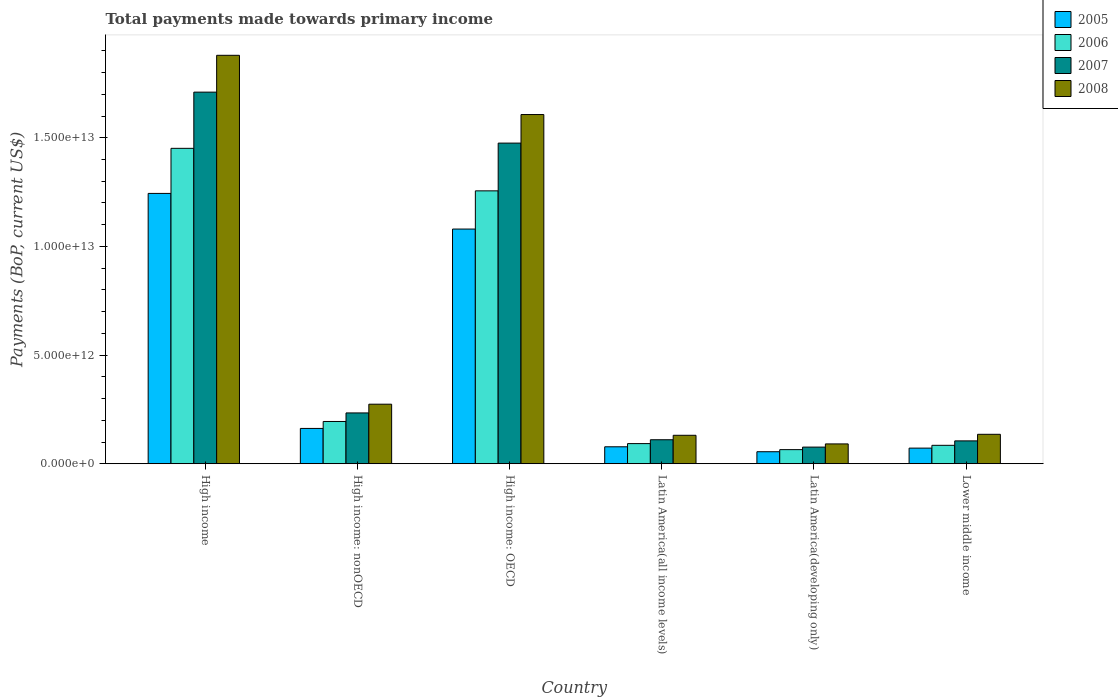How many different coloured bars are there?
Your answer should be compact. 4. How many groups of bars are there?
Provide a succinct answer. 6. Are the number of bars per tick equal to the number of legend labels?
Your response must be concise. Yes. Are the number of bars on each tick of the X-axis equal?
Provide a succinct answer. Yes. What is the label of the 5th group of bars from the left?
Provide a succinct answer. Latin America(developing only). In how many cases, is the number of bars for a given country not equal to the number of legend labels?
Provide a succinct answer. 0. What is the total payments made towards primary income in 2008 in High income: OECD?
Your response must be concise. 1.61e+13. Across all countries, what is the maximum total payments made towards primary income in 2007?
Offer a terse response. 1.71e+13. Across all countries, what is the minimum total payments made towards primary income in 2005?
Your answer should be very brief. 5.52e+11. In which country was the total payments made towards primary income in 2007 minimum?
Give a very brief answer. Latin America(developing only). What is the total total payments made towards primary income in 2008 in the graph?
Offer a terse response. 4.12e+13. What is the difference between the total payments made towards primary income in 2005 in High income and that in Latin America(all income levels)?
Offer a terse response. 1.17e+13. What is the difference between the total payments made towards primary income in 2006 in High income: OECD and the total payments made towards primary income in 2008 in Latin America(developing only)?
Your response must be concise. 1.16e+13. What is the average total payments made towards primary income in 2007 per country?
Your answer should be very brief. 6.19e+12. What is the difference between the total payments made towards primary income of/in 2007 and total payments made towards primary income of/in 2005 in High income: nonOECD?
Offer a terse response. 7.13e+11. In how many countries, is the total payments made towards primary income in 2005 greater than 10000000000000 US$?
Your answer should be compact. 2. What is the ratio of the total payments made towards primary income in 2005 in High income to that in Latin America(all income levels)?
Your answer should be compact. 15.95. What is the difference between the highest and the second highest total payments made towards primary income in 2006?
Your answer should be compact. 1.06e+13. What is the difference between the highest and the lowest total payments made towards primary income in 2005?
Keep it short and to the point. 1.19e+13. Is the sum of the total payments made towards primary income in 2008 in Latin America(all income levels) and Lower middle income greater than the maximum total payments made towards primary income in 2007 across all countries?
Provide a short and direct response. No. Is it the case that in every country, the sum of the total payments made towards primary income in 2007 and total payments made towards primary income in 2008 is greater than the sum of total payments made towards primary income in 2006 and total payments made towards primary income in 2005?
Your response must be concise. No. Are all the bars in the graph horizontal?
Provide a succinct answer. No. How many countries are there in the graph?
Give a very brief answer. 6. What is the difference between two consecutive major ticks on the Y-axis?
Ensure brevity in your answer.  5.00e+12. Does the graph contain grids?
Provide a succinct answer. No. What is the title of the graph?
Ensure brevity in your answer.  Total payments made towards primary income. What is the label or title of the Y-axis?
Keep it short and to the point. Payments (BoP, current US$). What is the Payments (BoP, current US$) of 2005 in High income?
Your response must be concise. 1.24e+13. What is the Payments (BoP, current US$) of 2006 in High income?
Make the answer very short. 1.45e+13. What is the Payments (BoP, current US$) in 2007 in High income?
Ensure brevity in your answer.  1.71e+13. What is the Payments (BoP, current US$) of 2008 in High income?
Your response must be concise. 1.88e+13. What is the Payments (BoP, current US$) of 2005 in High income: nonOECD?
Offer a terse response. 1.62e+12. What is the Payments (BoP, current US$) of 2006 in High income: nonOECD?
Keep it short and to the point. 1.94e+12. What is the Payments (BoP, current US$) in 2007 in High income: nonOECD?
Give a very brief answer. 2.34e+12. What is the Payments (BoP, current US$) of 2008 in High income: nonOECD?
Your answer should be compact. 2.74e+12. What is the Payments (BoP, current US$) in 2005 in High income: OECD?
Your answer should be compact. 1.08e+13. What is the Payments (BoP, current US$) in 2006 in High income: OECD?
Give a very brief answer. 1.26e+13. What is the Payments (BoP, current US$) in 2007 in High income: OECD?
Offer a very short reply. 1.48e+13. What is the Payments (BoP, current US$) in 2008 in High income: OECD?
Your answer should be compact. 1.61e+13. What is the Payments (BoP, current US$) of 2005 in Latin America(all income levels)?
Make the answer very short. 7.80e+11. What is the Payments (BoP, current US$) in 2006 in Latin America(all income levels)?
Your response must be concise. 9.27e+11. What is the Payments (BoP, current US$) of 2007 in Latin America(all income levels)?
Your answer should be very brief. 1.10e+12. What is the Payments (BoP, current US$) in 2008 in Latin America(all income levels)?
Keep it short and to the point. 1.31e+12. What is the Payments (BoP, current US$) in 2005 in Latin America(developing only)?
Your response must be concise. 5.52e+11. What is the Payments (BoP, current US$) of 2006 in Latin America(developing only)?
Offer a very short reply. 6.49e+11. What is the Payments (BoP, current US$) of 2007 in Latin America(developing only)?
Offer a terse response. 7.65e+11. What is the Payments (BoP, current US$) of 2008 in Latin America(developing only)?
Ensure brevity in your answer.  9.12e+11. What is the Payments (BoP, current US$) of 2005 in Lower middle income?
Provide a short and direct response. 7.19e+11. What is the Payments (BoP, current US$) in 2006 in Lower middle income?
Provide a short and direct response. 8.48e+11. What is the Payments (BoP, current US$) in 2007 in Lower middle income?
Offer a terse response. 1.05e+12. What is the Payments (BoP, current US$) of 2008 in Lower middle income?
Your answer should be very brief. 1.35e+12. Across all countries, what is the maximum Payments (BoP, current US$) of 2005?
Offer a terse response. 1.24e+13. Across all countries, what is the maximum Payments (BoP, current US$) of 2006?
Make the answer very short. 1.45e+13. Across all countries, what is the maximum Payments (BoP, current US$) in 2007?
Keep it short and to the point. 1.71e+13. Across all countries, what is the maximum Payments (BoP, current US$) of 2008?
Give a very brief answer. 1.88e+13. Across all countries, what is the minimum Payments (BoP, current US$) in 2005?
Offer a terse response. 5.52e+11. Across all countries, what is the minimum Payments (BoP, current US$) of 2006?
Your answer should be very brief. 6.49e+11. Across all countries, what is the minimum Payments (BoP, current US$) of 2007?
Keep it short and to the point. 7.65e+11. Across all countries, what is the minimum Payments (BoP, current US$) of 2008?
Keep it short and to the point. 9.12e+11. What is the total Payments (BoP, current US$) in 2005 in the graph?
Provide a succinct answer. 2.69e+13. What is the total Payments (BoP, current US$) in 2006 in the graph?
Make the answer very short. 3.14e+13. What is the total Payments (BoP, current US$) of 2007 in the graph?
Offer a terse response. 3.71e+13. What is the total Payments (BoP, current US$) of 2008 in the graph?
Give a very brief answer. 4.12e+13. What is the difference between the Payments (BoP, current US$) of 2005 in High income and that in High income: nonOECD?
Your answer should be compact. 1.08e+13. What is the difference between the Payments (BoP, current US$) of 2006 in High income and that in High income: nonOECD?
Provide a succinct answer. 1.26e+13. What is the difference between the Payments (BoP, current US$) of 2007 in High income and that in High income: nonOECD?
Provide a succinct answer. 1.48e+13. What is the difference between the Payments (BoP, current US$) in 2008 in High income and that in High income: nonOECD?
Give a very brief answer. 1.61e+13. What is the difference between the Payments (BoP, current US$) of 2005 in High income and that in High income: OECD?
Ensure brevity in your answer.  1.64e+12. What is the difference between the Payments (BoP, current US$) in 2006 in High income and that in High income: OECD?
Provide a succinct answer. 1.96e+12. What is the difference between the Payments (BoP, current US$) in 2007 in High income and that in High income: OECD?
Keep it short and to the point. 2.35e+12. What is the difference between the Payments (BoP, current US$) of 2008 in High income and that in High income: OECD?
Ensure brevity in your answer.  2.73e+12. What is the difference between the Payments (BoP, current US$) in 2005 in High income and that in Latin America(all income levels)?
Provide a succinct answer. 1.17e+13. What is the difference between the Payments (BoP, current US$) of 2006 in High income and that in Latin America(all income levels)?
Your answer should be compact. 1.36e+13. What is the difference between the Payments (BoP, current US$) in 2007 in High income and that in Latin America(all income levels)?
Your answer should be very brief. 1.60e+13. What is the difference between the Payments (BoP, current US$) of 2008 in High income and that in Latin America(all income levels)?
Make the answer very short. 1.75e+13. What is the difference between the Payments (BoP, current US$) of 2005 in High income and that in Latin America(developing only)?
Offer a terse response. 1.19e+13. What is the difference between the Payments (BoP, current US$) of 2006 in High income and that in Latin America(developing only)?
Offer a terse response. 1.39e+13. What is the difference between the Payments (BoP, current US$) of 2007 in High income and that in Latin America(developing only)?
Make the answer very short. 1.63e+13. What is the difference between the Payments (BoP, current US$) in 2008 in High income and that in Latin America(developing only)?
Your response must be concise. 1.79e+13. What is the difference between the Payments (BoP, current US$) of 2005 in High income and that in Lower middle income?
Offer a terse response. 1.17e+13. What is the difference between the Payments (BoP, current US$) in 2006 in High income and that in Lower middle income?
Ensure brevity in your answer.  1.37e+13. What is the difference between the Payments (BoP, current US$) of 2007 in High income and that in Lower middle income?
Your answer should be compact. 1.60e+13. What is the difference between the Payments (BoP, current US$) of 2008 in High income and that in Lower middle income?
Your response must be concise. 1.74e+13. What is the difference between the Payments (BoP, current US$) of 2005 in High income: nonOECD and that in High income: OECD?
Your response must be concise. -9.17e+12. What is the difference between the Payments (BoP, current US$) of 2006 in High income: nonOECD and that in High income: OECD?
Offer a terse response. -1.06e+13. What is the difference between the Payments (BoP, current US$) of 2007 in High income: nonOECD and that in High income: OECD?
Your response must be concise. -1.24e+13. What is the difference between the Payments (BoP, current US$) in 2008 in High income: nonOECD and that in High income: OECD?
Your response must be concise. -1.33e+13. What is the difference between the Payments (BoP, current US$) of 2005 in High income: nonOECD and that in Latin America(all income levels)?
Your answer should be compact. 8.45e+11. What is the difference between the Payments (BoP, current US$) of 2006 in High income: nonOECD and that in Latin America(all income levels)?
Keep it short and to the point. 1.02e+12. What is the difference between the Payments (BoP, current US$) of 2007 in High income: nonOECD and that in Latin America(all income levels)?
Keep it short and to the point. 1.23e+12. What is the difference between the Payments (BoP, current US$) in 2008 in High income: nonOECD and that in Latin America(all income levels)?
Provide a succinct answer. 1.43e+12. What is the difference between the Payments (BoP, current US$) in 2005 in High income: nonOECD and that in Latin America(developing only)?
Your answer should be very brief. 1.07e+12. What is the difference between the Payments (BoP, current US$) of 2006 in High income: nonOECD and that in Latin America(developing only)?
Your response must be concise. 1.30e+12. What is the difference between the Payments (BoP, current US$) of 2007 in High income: nonOECD and that in Latin America(developing only)?
Your answer should be very brief. 1.57e+12. What is the difference between the Payments (BoP, current US$) in 2008 in High income: nonOECD and that in Latin America(developing only)?
Your answer should be very brief. 1.83e+12. What is the difference between the Payments (BoP, current US$) of 2005 in High income: nonOECD and that in Lower middle income?
Offer a terse response. 9.06e+11. What is the difference between the Payments (BoP, current US$) of 2006 in High income: nonOECD and that in Lower middle income?
Ensure brevity in your answer.  1.10e+12. What is the difference between the Payments (BoP, current US$) of 2007 in High income: nonOECD and that in Lower middle income?
Offer a terse response. 1.29e+12. What is the difference between the Payments (BoP, current US$) of 2008 in High income: nonOECD and that in Lower middle income?
Your answer should be compact. 1.39e+12. What is the difference between the Payments (BoP, current US$) of 2005 in High income: OECD and that in Latin America(all income levels)?
Your answer should be compact. 1.00e+13. What is the difference between the Payments (BoP, current US$) in 2006 in High income: OECD and that in Latin America(all income levels)?
Your response must be concise. 1.16e+13. What is the difference between the Payments (BoP, current US$) in 2007 in High income: OECD and that in Latin America(all income levels)?
Provide a short and direct response. 1.36e+13. What is the difference between the Payments (BoP, current US$) of 2008 in High income: OECD and that in Latin America(all income levels)?
Provide a succinct answer. 1.48e+13. What is the difference between the Payments (BoP, current US$) of 2005 in High income: OECD and that in Latin America(developing only)?
Give a very brief answer. 1.02e+13. What is the difference between the Payments (BoP, current US$) of 2006 in High income: OECD and that in Latin America(developing only)?
Provide a succinct answer. 1.19e+13. What is the difference between the Payments (BoP, current US$) in 2007 in High income: OECD and that in Latin America(developing only)?
Provide a succinct answer. 1.40e+13. What is the difference between the Payments (BoP, current US$) of 2008 in High income: OECD and that in Latin America(developing only)?
Your response must be concise. 1.52e+13. What is the difference between the Payments (BoP, current US$) in 2005 in High income: OECD and that in Lower middle income?
Make the answer very short. 1.01e+13. What is the difference between the Payments (BoP, current US$) in 2006 in High income: OECD and that in Lower middle income?
Keep it short and to the point. 1.17e+13. What is the difference between the Payments (BoP, current US$) of 2007 in High income: OECD and that in Lower middle income?
Offer a very short reply. 1.37e+13. What is the difference between the Payments (BoP, current US$) of 2008 in High income: OECD and that in Lower middle income?
Offer a terse response. 1.47e+13. What is the difference between the Payments (BoP, current US$) in 2005 in Latin America(all income levels) and that in Latin America(developing only)?
Make the answer very short. 2.27e+11. What is the difference between the Payments (BoP, current US$) of 2006 in Latin America(all income levels) and that in Latin America(developing only)?
Your answer should be very brief. 2.78e+11. What is the difference between the Payments (BoP, current US$) of 2007 in Latin America(all income levels) and that in Latin America(developing only)?
Give a very brief answer. 3.39e+11. What is the difference between the Payments (BoP, current US$) of 2008 in Latin America(all income levels) and that in Latin America(developing only)?
Make the answer very short. 3.97e+11. What is the difference between the Payments (BoP, current US$) of 2005 in Latin America(all income levels) and that in Lower middle income?
Your answer should be compact. 6.05e+1. What is the difference between the Payments (BoP, current US$) in 2006 in Latin America(all income levels) and that in Lower middle income?
Provide a short and direct response. 7.89e+1. What is the difference between the Payments (BoP, current US$) of 2007 in Latin America(all income levels) and that in Lower middle income?
Offer a terse response. 5.23e+1. What is the difference between the Payments (BoP, current US$) of 2008 in Latin America(all income levels) and that in Lower middle income?
Your answer should be compact. -4.54e+1. What is the difference between the Payments (BoP, current US$) in 2005 in Latin America(developing only) and that in Lower middle income?
Provide a succinct answer. -1.67e+11. What is the difference between the Payments (BoP, current US$) of 2006 in Latin America(developing only) and that in Lower middle income?
Offer a terse response. -1.99e+11. What is the difference between the Payments (BoP, current US$) in 2007 in Latin America(developing only) and that in Lower middle income?
Provide a short and direct response. -2.86e+11. What is the difference between the Payments (BoP, current US$) of 2008 in Latin America(developing only) and that in Lower middle income?
Give a very brief answer. -4.42e+11. What is the difference between the Payments (BoP, current US$) in 2005 in High income and the Payments (BoP, current US$) in 2006 in High income: nonOECD?
Offer a very short reply. 1.05e+13. What is the difference between the Payments (BoP, current US$) of 2005 in High income and the Payments (BoP, current US$) of 2007 in High income: nonOECD?
Ensure brevity in your answer.  1.01e+13. What is the difference between the Payments (BoP, current US$) in 2005 in High income and the Payments (BoP, current US$) in 2008 in High income: nonOECD?
Keep it short and to the point. 9.70e+12. What is the difference between the Payments (BoP, current US$) in 2006 in High income and the Payments (BoP, current US$) in 2007 in High income: nonOECD?
Provide a succinct answer. 1.22e+13. What is the difference between the Payments (BoP, current US$) of 2006 in High income and the Payments (BoP, current US$) of 2008 in High income: nonOECD?
Give a very brief answer. 1.18e+13. What is the difference between the Payments (BoP, current US$) in 2007 in High income and the Payments (BoP, current US$) in 2008 in High income: nonOECD?
Keep it short and to the point. 1.44e+13. What is the difference between the Payments (BoP, current US$) in 2005 in High income and the Payments (BoP, current US$) in 2006 in High income: OECD?
Your response must be concise. -1.18e+11. What is the difference between the Payments (BoP, current US$) in 2005 in High income and the Payments (BoP, current US$) in 2007 in High income: OECD?
Give a very brief answer. -2.32e+12. What is the difference between the Payments (BoP, current US$) in 2005 in High income and the Payments (BoP, current US$) in 2008 in High income: OECD?
Offer a terse response. -3.63e+12. What is the difference between the Payments (BoP, current US$) of 2006 in High income and the Payments (BoP, current US$) of 2007 in High income: OECD?
Provide a short and direct response. -2.41e+11. What is the difference between the Payments (BoP, current US$) in 2006 in High income and the Payments (BoP, current US$) in 2008 in High income: OECD?
Make the answer very short. -1.55e+12. What is the difference between the Payments (BoP, current US$) of 2007 in High income and the Payments (BoP, current US$) of 2008 in High income: OECD?
Offer a very short reply. 1.03e+12. What is the difference between the Payments (BoP, current US$) of 2005 in High income and the Payments (BoP, current US$) of 2006 in Latin America(all income levels)?
Your answer should be very brief. 1.15e+13. What is the difference between the Payments (BoP, current US$) of 2005 in High income and the Payments (BoP, current US$) of 2007 in Latin America(all income levels)?
Make the answer very short. 1.13e+13. What is the difference between the Payments (BoP, current US$) of 2005 in High income and the Payments (BoP, current US$) of 2008 in Latin America(all income levels)?
Your response must be concise. 1.11e+13. What is the difference between the Payments (BoP, current US$) of 2006 in High income and the Payments (BoP, current US$) of 2007 in Latin America(all income levels)?
Ensure brevity in your answer.  1.34e+13. What is the difference between the Payments (BoP, current US$) of 2006 in High income and the Payments (BoP, current US$) of 2008 in Latin America(all income levels)?
Offer a very short reply. 1.32e+13. What is the difference between the Payments (BoP, current US$) of 2007 in High income and the Payments (BoP, current US$) of 2008 in Latin America(all income levels)?
Keep it short and to the point. 1.58e+13. What is the difference between the Payments (BoP, current US$) of 2005 in High income and the Payments (BoP, current US$) of 2006 in Latin America(developing only)?
Offer a very short reply. 1.18e+13. What is the difference between the Payments (BoP, current US$) of 2005 in High income and the Payments (BoP, current US$) of 2007 in Latin America(developing only)?
Your answer should be very brief. 1.17e+13. What is the difference between the Payments (BoP, current US$) of 2005 in High income and the Payments (BoP, current US$) of 2008 in Latin America(developing only)?
Your answer should be compact. 1.15e+13. What is the difference between the Payments (BoP, current US$) in 2006 in High income and the Payments (BoP, current US$) in 2007 in Latin America(developing only)?
Your answer should be compact. 1.37e+13. What is the difference between the Payments (BoP, current US$) in 2006 in High income and the Payments (BoP, current US$) in 2008 in Latin America(developing only)?
Provide a succinct answer. 1.36e+13. What is the difference between the Payments (BoP, current US$) of 2007 in High income and the Payments (BoP, current US$) of 2008 in Latin America(developing only)?
Keep it short and to the point. 1.62e+13. What is the difference between the Payments (BoP, current US$) in 2005 in High income and the Payments (BoP, current US$) in 2006 in Lower middle income?
Offer a very short reply. 1.16e+13. What is the difference between the Payments (BoP, current US$) of 2005 in High income and the Payments (BoP, current US$) of 2007 in Lower middle income?
Offer a very short reply. 1.14e+13. What is the difference between the Payments (BoP, current US$) in 2005 in High income and the Payments (BoP, current US$) in 2008 in Lower middle income?
Your response must be concise. 1.11e+13. What is the difference between the Payments (BoP, current US$) of 2006 in High income and the Payments (BoP, current US$) of 2007 in Lower middle income?
Your answer should be compact. 1.35e+13. What is the difference between the Payments (BoP, current US$) in 2006 in High income and the Payments (BoP, current US$) in 2008 in Lower middle income?
Provide a succinct answer. 1.32e+13. What is the difference between the Payments (BoP, current US$) in 2007 in High income and the Payments (BoP, current US$) in 2008 in Lower middle income?
Your answer should be very brief. 1.57e+13. What is the difference between the Payments (BoP, current US$) in 2005 in High income: nonOECD and the Payments (BoP, current US$) in 2006 in High income: OECD?
Your response must be concise. -1.09e+13. What is the difference between the Payments (BoP, current US$) in 2005 in High income: nonOECD and the Payments (BoP, current US$) in 2007 in High income: OECD?
Provide a succinct answer. -1.31e+13. What is the difference between the Payments (BoP, current US$) in 2005 in High income: nonOECD and the Payments (BoP, current US$) in 2008 in High income: OECD?
Keep it short and to the point. -1.44e+13. What is the difference between the Payments (BoP, current US$) in 2006 in High income: nonOECD and the Payments (BoP, current US$) in 2007 in High income: OECD?
Ensure brevity in your answer.  -1.28e+13. What is the difference between the Payments (BoP, current US$) of 2006 in High income: nonOECD and the Payments (BoP, current US$) of 2008 in High income: OECD?
Keep it short and to the point. -1.41e+13. What is the difference between the Payments (BoP, current US$) in 2007 in High income: nonOECD and the Payments (BoP, current US$) in 2008 in High income: OECD?
Offer a very short reply. -1.37e+13. What is the difference between the Payments (BoP, current US$) of 2005 in High income: nonOECD and the Payments (BoP, current US$) of 2006 in Latin America(all income levels)?
Offer a very short reply. 6.98e+11. What is the difference between the Payments (BoP, current US$) in 2005 in High income: nonOECD and the Payments (BoP, current US$) in 2007 in Latin America(all income levels)?
Your answer should be very brief. 5.21e+11. What is the difference between the Payments (BoP, current US$) in 2005 in High income: nonOECD and the Payments (BoP, current US$) in 2008 in Latin America(all income levels)?
Your response must be concise. 3.16e+11. What is the difference between the Payments (BoP, current US$) in 2006 in High income: nonOECD and the Payments (BoP, current US$) in 2007 in Latin America(all income levels)?
Your response must be concise. 8.40e+11. What is the difference between the Payments (BoP, current US$) of 2006 in High income: nonOECD and the Payments (BoP, current US$) of 2008 in Latin America(all income levels)?
Give a very brief answer. 6.35e+11. What is the difference between the Payments (BoP, current US$) of 2007 in High income: nonOECD and the Payments (BoP, current US$) of 2008 in Latin America(all income levels)?
Keep it short and to the point. 1.03e+12. What is the difference between the Payments (BoP, current US$) in 2005 in High income: nonOECD and the Payments (BoP, current US$) in 2006 in Latin America(developing only)?
Keep it short and to the point. 9.76e+11. What is the difference between the Payments (BoP, current US$) of 2005 in High income: nonOECD and the Payments (BoP, current US$) of 2007 in Latin America(developing only)?
Your answer should be very brief. 8.59e+11. What is the difference between the Payments (BoP, current US$) of 2005 in High income: nonOECD and the Payments (BoP, current US$) of 2008 in Latin America(developing only)?
Offer a very short reply. 7.13e+11. What is the difference between the Payments (BoP, current US$) of 2006 in High income: nonOECD and the Payments (BoP, current US$) of 2007 in Latin America(developing only)?
Keep it short and to the point. 1.18e+12. What is the difference between the Payments (BoP, current US$) of 2006 in High income: nonOECD and the Payments (BoP, current US$) of 2008 in Latin America(developing only)?
Offer a terse response. 1.03e+12. What is the difference between the Payments (BoP, current US$) of 2007 in High income: nonOECD and the Payments (BoP, current US$) of 2008 in Latin America(developing only)?
Your answer should be very brief. 1.43e+12. What is the difference between the Payments (BoP, current US$) of 2005 in High income: nonOECD and the Payments (BoP, current US$) of 2006 in Lower middle income?
Your response must be concise. 7.77e+11. What is the difference between the Payments (BoP, current US$) of 2005 in High income: nonOECD and the Payments (BoP, current US$) of 2007 in Lower middle income?
Ensure brevity in your answer.  5.73e+11. What is the difference between the Payments (BoP, current US$) of 2005 in High income: nonOECD and the Payments (BoP, current US$) of 2008 in Lower middle income?
Ensure brevity in your answer.  2.70e+11. What is the difference between the Payments (BoP, current US$) of 2006 in High income: nonOECD and the Payments (BoP, current US$) of 2007 in Lower middle income?
Offer a very short reply. 8.93e+11. What is the difference between the Payments (BoP, current US$) of 2006 in High income: nonOECD and the Payments (BoP, current US$) of 2008 in Lower middle income?
Offer a terse response. 5.90e+11. What is the difference between the Payments (BoP, current US$) of 2007 in High income: nonOECD and the Payments (BoP, current US$) of 2008 in Lower middle income?
Make the answer very short. 9.84e+11. What is the difference between the Payments (BoP, current US$) in 2005 in High income: OECD and the Payments (BoP, current US$) in 2006 in Latin America(all income levels)?
Your answer should be compact. 9.87e+12. What is the difference between the Payments (BoP, current US$) in 2005 in High income: OECD and the Payments (BoP, current US$) in 2007 in Latin America(all income levels)?
Give a very brief answer. 9.69e+12. What is the difference between the Payments (BoP, current US$) of 2005 in High income: OECD and the Payments (BoP, current US$) of 2008 in Latin America(all income levels)?
Ensure brevity in your answer.  9.49e+12. What is the difference between the Payments (BoP, current US$) of 2006 in High income: OECD and the Payments (BoP, current US$) of 2007 in Latin America(all income levels)?
Make the answer very short. 1.15e+13. What is the difference between the Payments (BoP, current US$) in 2006 in High income: OECD and the Payments (BoP, current US$) in 2008 in Latin America(all income levels)?
Your response must be concise. 1.12e+13. What is the difference between the Payments (BoP, current US$) of 2007 in High income: OECD and the Payments (BoP, current US$) of 2008 in Latin America(all income levels)?
Your answer should be very brief. 1.34e+13. What is the difference between the Payments (BoP, current US$) of 2005 in High income: OECD and the Payments (BoP, current US$) of 2006 in Latin America(developing only)?
Provide a succinct answer. 1.01e+13. What is the difference between the Payments (BoP, current US$) of 2005 in High income: OECD and the Payments (BoP, current US$) of 2007 in Latin America(developing only)?
Offer a very short reply. 1.00e+13. What is the difference between the Payments (BoP, current US$) in 2005 in High income: OECD and the Payments (BoP, current US$) in 2008 in Latin America(developing only)?
Your response must be concise. 9.89e+12. What is the difference between the Payments (BoP, current US$) in 2006 in High income: OECD and the Payments (BoP, current US$) in 2007 in Latin America(developing only)?
Your response must be concise. 1.18e+13. What is the difference between the Payments (BoP, current US$) of 2006 in High income: OECD and the Payments (BoP, current US$) of 2008 in Latin America(developing only)?
Your answer should be very brief. 1.16e+13. What is the difference between the Payments (BoP, current US$) of 2007 in High income: OECD and the Payments (BoP, current US$) of 2008 in Latin America(developing only)?
Provide a short and direct response. 1.38e+13. What is the difference between the Payments (BoP, current US$) in 2005 in High income: OECD and the Payments (BoP, current US$) in 2006 in Lower middle income?
Make the answer very short. 9.95e+12. What is the difference between the Payments (BoP, current US$) of 2005 in High income: OECD and the Payments (BoP, current US$) of 2007 in Lower middle income?
Provide a short and direct response. 9.75e+12. What is the difference between the Payments (BoP, current US$) in 2005 in High income: OECD and the Payments (BoP, current US$) in 2008 in Lower middle income?
Offer a terse response. 9.44e+12. What is the difference between the Payments (BoP, current US$) of 2006 in High income: OECD and the Payments (BoP, current US$) of 2007 in Lower middle income?
Provide a succinct answer. 1.15e+13. What is the difference between the Payments (BoP, current US$) in 2006 in High income: OECD and the Payments (BoP, current US$) in 2008 in Lower middle income?
Offer a terse response. 1.12e+13. What is the difference between the Payments (BoP, current US$) in 2007 in High income: OECD and the Payments (BoP, current US$) in 2008 in Lower middle income?
Give a very brief answer. 1.34e+13. What is the difference between the Payments (BoP, current US$) of 2005 in Latin America(all income levels) and the Payments (BoP, current US$) of 2006 in Latin America(developing only)?
Your answer should be compact. 1.31e+11. What is the difference between the Payments (BoP, current US$) of 2005 in Latin America(all income levels) and the Payments (BoP, current US$) of 2007 in Latin America(developing only)?
Your answer should be very brief. 1.43e+1. What is the difference between the Payments (BoP, current US$) of 2005 in Latin America(all income levels) and the Payments (BoP, current US$) of 2008 in Latin America(developing only)?
Provide a short and direct response. -1.33e+11. What is the difference between the Payments (BoP, current US$) in 2006 in Latin America(all income levels) and the Payments (BoP, current US$) in 2007 in Latin America(developing only)?
Ensure brevity in your answer.  1.61e+11. What is the difference between the Payments (BoP, current US$) of 2006 in Latin America(all income levels) and the Payments (BoP, current US$) of 2008 in Latin America(developing only)?
Provide a short and direct response. 1.44e+1. What is the difference between the Payments (BoP, current US$) in 2007 in Latin America(all income levels) and the Payments (BoP, current US$) in 2008 in Latin America(developing only)?
Offer a very short reply. 1.92e+11. What is the difference between the Payments (BoP, current US$) of 2005 in Latin America(all income levels) and the Payments (BoP, current US$) of 2006 in Lower middle income?
Offer a terse response. -6.81e+1. What is the difference between the Payments (BoP, current US$) in 2005 in Latin America(all income levels) and the Payments (BoP, current US$) in 2007 in Lower middle income?
Make the answer very short. -2.72e+11. What is the difference between the Payments (BoP, current US$) of 2005 in Latin America(all income levels) and the Payments (BoP, current US$) of 2008 in Lower middle income?
Your answer should be very brief. -5.75e+11. What is the difference between the Payments (BoP, current US$) in 2006 in Latin America(all income levels) and the Payments (BoP, current US$) in 2007 in Lower middle income?
Ensure brevity in your answer.  -1.25e+11. What is the difference between the Payments (BoP, current US$) in 2006 in Latin America(all income levels) and the Payments (BoP, current US$) in 2008 in Lower middle income?
Offer a very short reply. -4.28e+11. What is the difference between the Payments (BoP, current US$) of 2007 in Latin America(all income levels) and the Payments (BoP, current US$) of 2008 in Lower middle income?
Your answer should be very brief. -2.50e+11. What is the difference between the Payments (BoP, current US$) of 2005 in Latin America(developing only) and the Payments (BoP, current US$) of 2006 in Lower middle income?
Your response must be concise. -2.95e+11. What is the difference between the Payments (BoP, current US$) of 2005 in Latin America(developing only) and the Payments (BoP, current US$) of 2007 in Lower middle income?
Ensure brevity in your answer.  -4.99e+11. What is the difference between the Payments (BoP, current US$) in 2005 in Latin America(developing only) and the Payments (BoP, current US$) in 2008 in Lower middle income?
Offer a terse response. -8.02e+11. What is the difference between the Payments (BoP, current US$) of 2006 in Latin America(developing only) and the Payments (BoP, current US$) of 2007 in Lower middle income?
Make the answer very short. -4.03e+11. What is the difference between the Payments (BoP, current US$) in 2006 in Latin America(developing only) and the Payments (BoP, current US$) in 2008 in Lower middle income?
Ensure brevity in your answer.  -7.05e+11. What is the difference between the Payments (BoP, current US$) of 2007 in Latin America(developing only) and the Payments (BoP, current US$) of 2008 in Lower middle income?
Provide a short and direct response. -5.89e+11. What is the average Payments (BoP, current US$) in 2005 per country?
Provide a succinct answer. 4.49e+12. What is the average Payments (BoP, current US$) in 2006 per country?
Give a very brief answer. 5.24e+12. What is the average Payments (BoP, current US$) in 2007 per country?
Ensure brevity in your answer.  6.19e+12. What is the average Payments (BoP, current US$) in 2008 per country?
Make the answer very short. 6.86e+12. What is the difference between the Payments (BoP, current US$) of 2005 and Payments (BoP, current US$) of 2006 in High income?
Your answer should be very brief. -2.07e+12. What is the difference between the Payments (BoP, current US$) in 2005 and Payments (BoP, current US$) in 2007 in High income?
Keep it short and to the point. -4.66e+12. What is the difference between the Payments (BoP, current US$) in 2005 and Payments (BoP, current US$) in 2008 in High income?
Your response must be concise. -6.36e+12. What is the difference between the Payments (BoP, current US$) in 2006 and Payments (BoP, current US$) in 2007 in High income?
Your answer should be compact. -2.59e+12. What is the difference between the Payments (BoP, current US$) of 2006 and Payments (BoP, current US$) of 2008 in High income?
Offer a terse response. -4.28e+12. What is the difference between the Payments (BoP, current US$) of 2007 and Payments (BoP, current US$) of 2008 in High income?
Your answer should be very brief. -1.69e+12. What is the difference between the Payments (BoP, current US$) in 2005 and Payments (BoP, current US$) in 2006 in High income: nonOECD?
Make the answer very short. -3.20e+11. What is the difference between the Payments (BoP, current US$) in 2005 and Payments (BoP, current US$) in 2007 in High income: nonOECD?
Ensure brevity in your answer.  -7.13e+11. What is the difference between the Payments (BoP, current US$) of 2005 and Payments (BoP, current US$) of 2008 in High income: nonOECD?
Ensure brevity in your answer.  -1.12e+12. What is the difference between the Payments (BoP, current US$) in 2006 and Payments (BoP, current US$) in 2007 in High income: nonOECD?
Make the answer very short. -3.94e+11. What is the difference between the Payments (BoP, current US$) in 2006 and Payments (BoP, current US$) in 2008 in High income: nonOECD?
Provide a succinct answer. -7.96e+11. What is the difference between the Payments (BoP, current US$) in 2007 and Payments (BoP, current US$) in 2008 in High income: nonOECD?
Provide a succinct answer. -4.02e+11. What is the difference between the Payments (BoP, current US$) in 2005 and Payments (BoP, current US$) in 2006 in High income: OECD?
Your answer should be very brief. -1.76e+12. What is the difference between the Payments (BoP, current US$) of 2005 and Payments (BoP, current US$) of 2007 in High income: OECD?
Your answer should be very brief. -3.96e+12. What is the difference between the Payments (BoP, current US$) of 2005 and Payments (BoP, current US$) of 2008 in High income: OECD?
Make the answer very short. -5.27e+12. What is the difference between the Payments (BoP, current US$) in 2006 and Payments (BoP, current US$) in 2007 in High income: OECD?
Your response must be concise. -2.20e+12. What is the difference between the Payments (BoP, current US$) in 2006 and Payments (BoP, current US$) in 2008 in High income: OECD?
Ensure brevity in your answer.  -3.51e+12. What is the difference between the Payments (BoP, current US$) of 2007 and Payments (BoP, current US$) of 2008 in High income: OECD?
Offer a terse response. -1.31e+12. What is the difference between the Payments (BoP, current US$) in 2005 and Payments (BoP, current US$) in 2006 in Latin America(all income levels)?
Provide a succinct answer. -1.47e+11. What is the difference between the Payments (BoP, current US$) of 2005 and Payments (BoP, current US$) of 2007 in Latin America(all income levels)?
Ensure brevity in your answer.  -3.25e+11. What is the difference between the Payments (BoP, current US$) of 2005 and Payments (BoP, current US$) of 2008 in Latin America(all income levels)?
Offer a terse response. -5.29e+11. What is the difference between the Payments (BoP, current US$) of 2006 and Payments (BoP, current US$) of 2007 in Latin America(all income levels)?
Make the answer very short. -1.78e+11. What is the difference between the Payments (BoP, current US$) of 2006 and Payments (BoP, current US$) of 2008 in Latin America(all income levels)?
Your answer should be compact. -3.82e+11. What is the difference between the Payments (BoP, current US$) of 2007 and Payments (BoP, current US$) of 2008 in Latin America(all income levels)?
Provide a succinct answer. -2.05e+11. What is the difference between the Payments (BoP, current US$) in 2005 and Payments (BoP, current US$) in 2006 in Latin America(developing only)?
Your answer should be compact. -9.65e+1. What is the difference between the Payments (BoP, current US$) in 2005 and Payments (BoP, current US$) in 2007 in Latin America(developing only)?
Provide a succinct answer. -2.13e+11. What is the difference between the Payments (BoP, current US$) in 2005 and Payments (BoP, current US$) in 2008 in Latin America(developing only)?
Provide a short and direct response. -3.60e+11. What is the difference between the Payments (BoP, current US$) in 2006 and Payments (BoP, current US$) in 2007 in Latin America(developing only)?
Offer a terse response. -1.16e+11. What is the difference between the Payments (BoP, current US$) in 2006 and Payments (BoP, current US$) in 2008 in Latin America(developing only)?
Your answer should be very brief. -2.63e+11. What is the difference between the Payments (BoP, current US$) of 2007 and Payments (BoP, current US$) of 2008 in Latin America(developing only)?
Your answer should be very brief. -1.47e+11. What is the difference between the Payments (BoP, current US$) in 2005 and Payments (BoP, current US$) in 2006 in Lower middle income?
Make the answer very short. -1.29e+11. What is the difference between the Payments (BoP, current US$) of 2005 and Payments (BoP, current US$) of 2007 in Lower middle income?
Make the answer very short. -3.33e+11. What is the difference between the Payments (BoP, current US$) in 2005 and Payments (BoP, current US$) in 2008 in Lower middle income?
Your answer should be very brief. -6.35e+11. What is the difference between the Payments (BoP, current US$) of 2006 and Payments (BoP, current US$) of 2007 in Lower middle income?
Your answer should be compact. -2.04e+11. What is the difference between the Payments (BoP, current US$) in 2006 and Payments (BoP, current US$) in 2008 in Lower middle income?
Give a very brief answer. -5.07e+11. What is the difference between the Payments (BoP, current US$) of 2007 and Payments (BoP, current US$) of 2008 in Lower middle income?
Provide a succinct answer. -3.03e+11. What is the ratio of the Payments (BoP, current US$) in 2005 in High income to that in High income: nonOECD?
Offer a very short reply. 7.66. What is the ratio of the Payments (BoP, current US$) of 2006 in High income to that in High income: nonOECD?
Your answer should be compact. 7.46. What is the ratio of the Payments (BoP, current US$) of 2007 in High income to that in High income: nonOECD?
Your answer should be very brief. 7.31. What is the ratio of the Payments (BoP, current US$) in 2008 in High income to that in High income: nonOECD?
Keep it short and to the point. 6.86. What is the ratio of the Payments (BoP, current US$) in 2005 in High income to that in High income: OECD?
Offer a terse response. 1.15. What is the ratio of the Payments (BoP, current US$) of 2006 in High income to that in High income: OECD?
Your response must be concise. 1.16. What is the ratio of the Payments (BoP, current US$) in 2007 in High income to that in High income: OECD?
Keep it short and to the point. 1.16. What is the ratio of the Payments (BoP, current US$) of 2008 in High income to that in High income: OECD?
Your answer should be compact. 1.17. What is the ratio of the Payments (BoP, current US$) of 2005 in High income to that in Latin America(all income levels)?
Offer a very short reply. 15.95. What is the ratio of the Payments (BoP, current US$) in 2006 in High income to that in Latin America(all income levels)?
Give a very brief answer. 15.66. What is the ratio of the Payments (BoP, current US$) in 2007 in High income to that in Latin America(all income levels)?
Keep it short and to the point. 15.49. What is the ratio of the Payments (BoP, current US$) in 2008 in High income to that in Latin America(all income levels)?
Offer a very short reply. 14.36. What is the ratio of the Payments (BoP, current US$) of 2005 in High income to that in Latin America(developing only)?
Provide a succinct answer. 22.51. What is the ratio of the Payments (BoP, current US$) in 2006 in High income to that in Latin America(developing only)?
Your answer should be compact. 22.36. What is the ratio of the Payments (BoP, current US$) in 2007 in High income to that in Latin America(developing only)?
Your answer should be very brief. 22.34. What is the ratio of the Payments (BoP, current US$) of 2008 in High income to that in Latin America(developing only)?
Your answer should be very brief. 20.6. What is the ratio of the Payments (BoP, current US$) in 2005 in High income to that in Lower middle income?
Make the answer very short. 17.3. What is the ratio of the Payments (BoP, current US$) in 2006 in High income to that in Lower middle income?
Your answer should be compact. 17.12. What is the ratio of the Payments (BoP, current US$) of 2007 in High income to that in Lower middle income?
Provide a succinct answer. 16.26. What is the ratio of the Payments (BoP, current US$) of 2008 in High income to that in Lower middle income?
Offer a very short reply. 13.88. What is the ratio of the Payments (BoP, current US$) in 2005 in High income: nonOECD to that in High income: OECD?
Give a very brief answer. 0.15. What is the ratio of the Payments (BoP, current US$) of 2006 in High income: nonOECD to that in High income: OECD?
Offer a very short reply. 0.15. What is the ratio of the Payments (BoP, current US$) in 2007 in High income: nonOECD to that in High income: OECD?
Provide a succinct answer. 0.16. What is the ratio of the Payments (BoP, current US$) in 2008 in High income: nonOECD to that in High income: OECD?
Your response must be concise. 0.17. What is the ratio of the Payments (BoP, current US$) of 2005 in High income: nonOECD to that in Latin America(all income levels)?
Offer a terse response. 2.08. What is the ratio of the Payments (BoP, current US$) in 2006 in High income: nonOECD to that in Latin America(all income levels)?
Your answer should be compact. 2.1. What is the ratio of the Payments (BoP, current US$) of 2007 in High income: nonOECD to that in Latin America(all income levels)?
Provide a short and direct response. 2.12. What is the ratio of the Payments (BoP, current US$) of 2008 in High income: nonOECD to that in Latin America(all income levels)?
Keep it short and to the point. 2.09. What is the ratio of the Payments (BoP, current US$) in 2005 in High income: nonOECD to that in Latin America(developing only)?
Offer a terse response. 2.94. What is the ratio of the Payments (BoP, current US$) in 2006 in High income: nonOECD to that in Latin America(developing only)?
Give a very brief answer. 3. What is the ratio of the Payments (BoP, current US$) in 2007 in High income: nonOECD to that in Latin America(developing only)?
Give a very brief answer. 3.06. What is the ratio of the Payments (BoP, current US$) of 2008 in High income: nonOECD to that in Latin America(developing only)?
Keep it short and to the point. 3. What is the ratio of the Payments (BoP, current US$) in 2005 in High income: nonOECD to that in Lower middle income?
Provide a short and direct response. 2.26. What is the ratio of the Payments (BoP, current US$) in 2006 in High income: nonOECD to that in Lower middle income?
Provide a short and direct response. 2.29. What is the ratio of the Payments (BoP, current US$) in 2007 in High income: nonOECD to that in Lower middle income?
Ensure brevity in your answer.  2.22. What is the ratio of the Payments (BoP, current US$) in 2008 in High income: nonOECD to that in Lower middle income?
Offer a terse response. 2.02. What is the ratio of the Payments (BoP, current US$) in 2005 in High income: OECD to that in Latin America(all income levels)?
Offer a terse response. 13.85. What is the ratio of the Payments (BoP, current US$) of 2006 in High income: OECD to that in Latin America(all income levels)?
Ensure brevity in your answer.  13.55. What is the ratio of the Payments (BoP, current US$) in 2007 in High income: OECD to that in Latin America(all income levels)?
Your response must be concise. 13.36. What is the ratio of the Payments (BoP, current US$) of 2008 in High income: OECD to that in Latin America(all income levels)?
Make the answer very short. 12.27. What is the ratio of the Payments (BoP, current US$) in 2005 in High income: OECD to that in Latin America(developing only)?
Your answer should be compact. 19.55. What is the ratio of the Payments (BoP, current US$) in 2006 in High income: OECD to that in Latin America(developing only)?
Your response must be concise. 19.35. What is the ratio of the Payments (BoP, current US$) in 2007 in High income: OECD to that in Latin America(developing only)?
Offer a very short reply. 19.28. What is the ratio of the Payments (BoP, current US$) in 2008 in High income: OECD to that in Latin America(developing only)?
Your response must be concise. 17.61. What is the ratio of the Payments (BoP, current US$) of 2005 in High income: OECD to that in Lower middle income?
Give a very brief answer. 15.02. What is the ratio of the Payments (BoP, current US$) of 2006 in High income: OECD to that in Lower middle income?
Offer a very short reply. 14.81. What is the ratio of the Payments (BoP, current US$) of 2007 in High income: OECD to that in Lower middle income?
Keep it short and to the point. 14.03. What is the ratio of the Payments (BoP, current US$) in 2008 in High income: OECD to that in Lower middle income?
Your answer should be very brief. 11.86. What is the ratio of the Payments (BoP, current US$) in 2005 in Latin America(all income levels) to that in Latin America(developing only)?
Make the answer very short. 1.41. What is the ratio of the Payments (BoP, current US$) of 2006 in Latin America(all income levels) to that in Latin America(developing only)?
Your answer should be compact. 1.43. What is the ratio of the Payments (BoP, current US$) of 2007 in Latin America(all income levels) to that in Latin America(developing only)?
Make the answer very short. 1.44. What is the ratio of the Payments (BoP, current US$) of 2008 in Latin America(all income levels) to that in Latin America(developing only)?
Your answer should be very brief. 1.44. What is the ratio of the Payments (BoP, current US$) in 2005 in Latin America(all income levels) to that in Lower middle income?
Offer a very short reply. 1.08. What is the ratio of the Payments (BoP, current US$) in 2006 in Latin America(all income levels) to that in Lower middle income?
Make the answer very short. 1.09. What is the ratio of the Payments (BoP, current US$) of 2007 in Latin America(all income levels) to that in Lower middle income?
Ensure brevity in your answer.  1.05. What is the ratio of the Payments (BoP, current US$) of 2008 in Latin America(all income levels) to that in Lower middle income?
Make the answer very short. 0.97. What is the ratio of the Payments (BoP, current US$) in 2005 in Latin America(developing only) to that in Lower middle income?
Provide a short and direct response. 0.77. What is the ratio of the Payments (BoP, current US$) in 2006 in Latin America(developing only) to that in Lower middle income?
Ensure brevity in your answer.  0.77. What is the ratio of the Payments (BoP, current US$) of 2007 in Latin America(developing only) to that in Lower middle income?
Give a very brief answer. 0.73. What is the ratio of the Payments (BoP, current US$) of 2008 in Latin America(developing only) to that in Lower middle income?
Your answer should be compact. 0.67. What is the difference between the highest and the second highest Payments (BoP, current US$) of 2005?
Give a very brief answer. 1.64e+12. What is the difference between the highest and the second highest Payments (BoP, current US$) of 2006?
Your answer should be very brief. 1.96e+12. What is the difference between the highest and the second highest Payments (BoP, current US$) in 2007?
Your response must be concise. 2.35e+12. What is the difference between the highest and the second highest Payments (BoP, current US$) in 2008?
Offer a terse response. 2.73e+12. What is the difference between the highest and the lowest Payments (BoP, current US$) of 2005?
Ensure brevity in your answer.  1.19e+13. What is the difference between the highest and the lowest Payments (BoP, current US$) in 2006?
Your response must be concise. 1.39e+13. What is the difference between the highest and the lowest Payments (BoP, current US$) of 2007?
Make the answer very short. 1.63e+13. What is the difference between the highest and the lowest Payments (BoP, current US$) in 2008?
Offer a very short reply. 1.79e+13. 